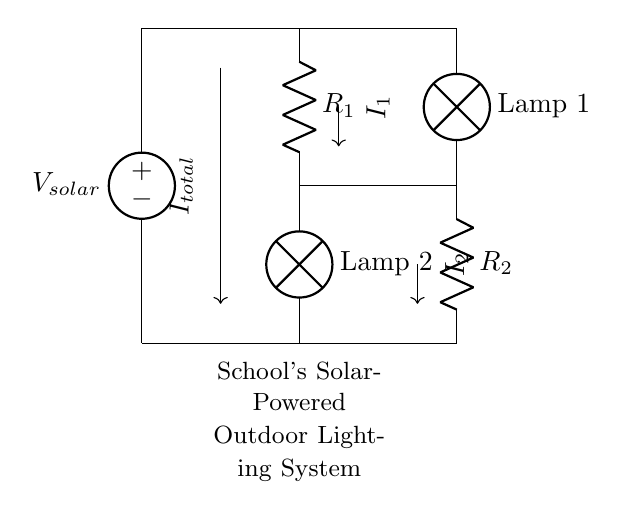What is the total current entering the circuit? The total current, denoted as I total, represents the amount of current supplied by the solar panel (V solar) to the circuit. It is indicated by the arrow merging from the top to the middle where the two branches split.
Answer: I total What are the components connected in parallel? The resistors R1 and R2 along with the lamps are connected in parallel, which is evident as they branch off from the same two nodes - the top node connected to V solar and the bottom node connected to ground.
Answer: R1, R2, Lamp 1, Lamp 2 What type of circuit is displayed in this diagram? The circuit shown is a current divider because it splits the incoming current into two branches (I1 and I2) that go through different components (the resistors and lamps). This behavior defines it as a current divider.
Answer: Current divider How does the current split between R1 and R2? The current splits based on the resistance values of R1 and R2, following Ohm's Law. If R1 is less than R2, then I1 will be greater than I2; conversely, if R1 is greater than R2, then I1 will be less than I2. The current division can be calculated using the formula I1 = I total * (R2 / (R1 + R2)).
Answer: Based on resistance values What is the role of the solar panel in this circuit? The solar panel (V solar) acts as a source of electrical energy, supplying the total voltage to the circuit, which then powers the lamps and flows through the resistors by creating a potential difference.
Answer: Voltage source 